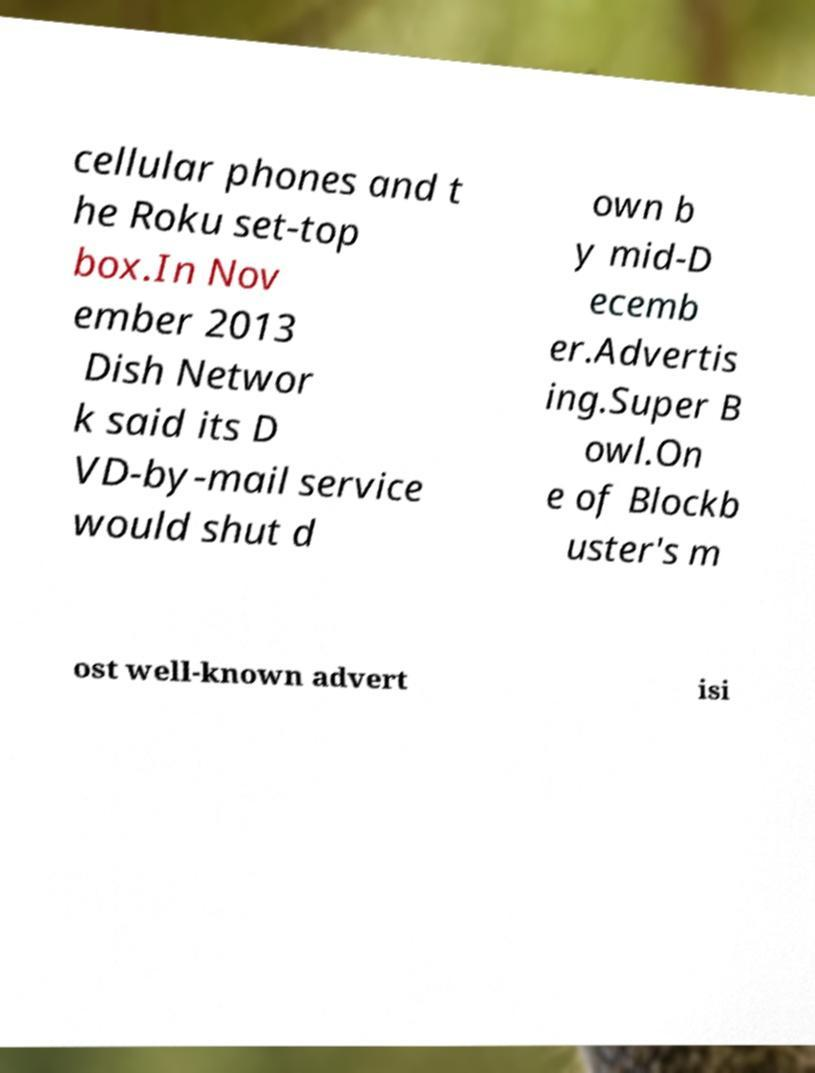What messages or text are displayed in this image? I need them in a readable, typed format. cellular phones and t he Roku set-top box.In Nov ember 2013 Dish Networ k said its D VD-by-mail service would shut d own b y mid-D ecemb er.Advertis ing.Super B owl.On e of Blockb uster's m ost well-known advert isi 